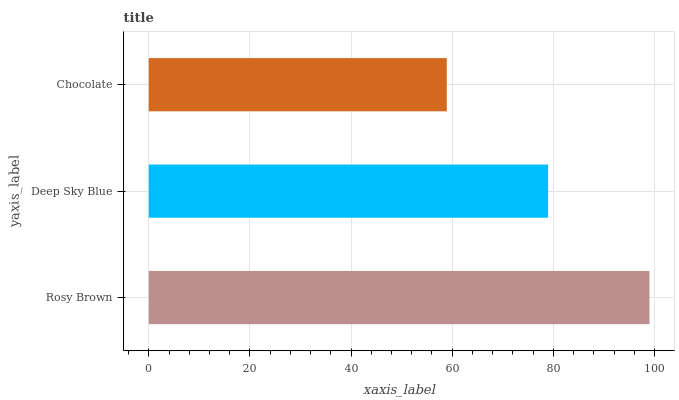Is Chocolate the minimum?
Answer yes or no. Yes. Is Rosy Brown the maximum?
Answer yes or no. Yes. Is Deep Sky Blue the minimum?
Answer yes or no. No. Is Deep Sky Blue the maximum?
Answer yes or no. No. Is Rosy Brown greater than Deep Sky Blue?
Answer yes or no. Yes. Is Deep Sky Blue less than Rosy Brown?
Answer yes or no. Yes. Is Deep Sky Blue greater than Rosy Brown?
Answer yes or no. No. Is Rosy Brown less than Deep Sky Blue?
Answer yes or no. No. Is Deep Sky Blue the high median?
Answer yes or no. Yes. Is Deep Sky Blue the low median?
Answer yes or no. Yes. Is Rosy Brown the high median?
Answer yes or no. No. Is Rosy Brown the low median?
Answer yes or no. No. 